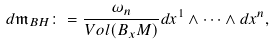Convert formula to latex. <formula><loc_0><loc_0><loc_500><loc_500>d \mathfrak { m } _ { B H } \colon = \frac { \omega _ { n } } { V o l ( B _ { x } M ) } d x ^ { 1 } \wedge \dots \wedge d x ^ { n } ,</formula> 